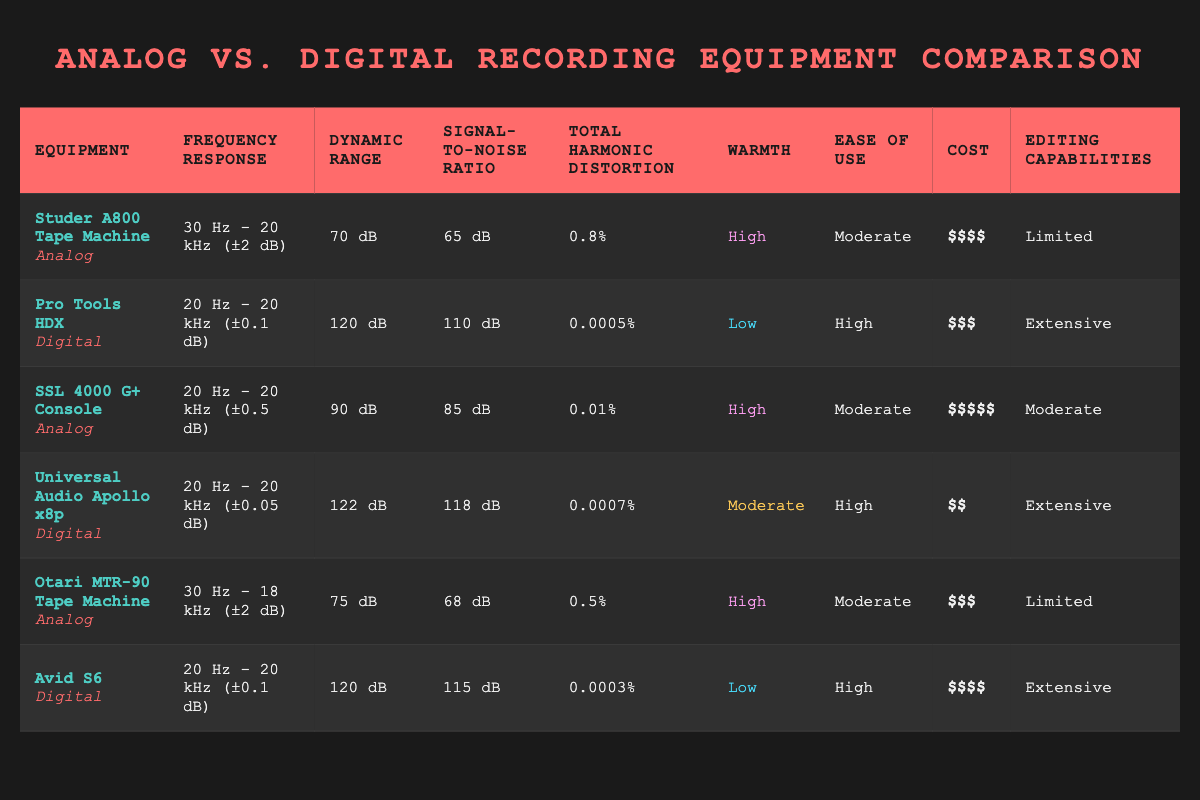What is the frequency response of Pro Tools HDX? The frequency response of Pro Tools HDX is listed in the table as 20 Hz - 20 kHz (±0.1 dB).
Answer: 20 Hz - 20 kHz (±0.1 dB) Which equipment has the highest dynamic range? Looking at the dynamic ranges provided in the table, Pro Tools HDX has a dynamic range of 120 dB, which is the highest among all listed equipment.
Answer: Pro Tools HDX True or false: The Studer A800 Tape Machine has a better signal-to-noise ratio than the Otari MTR-90 Tape Machine. The signal-to-noise ratio for the Studer A800 is 65 dB, and the Otari MTR-90 is 68 dB. Since 65 dB is less than 68 dB, the statement is false.
Answer: False What is the difference in total harmonic distortion between the Universal Audio Apollo x8p and the SSL 4000 G+ Console? The total harmonic distortion for the Universal Audio Apollo x8p is 0.0007%, and for the SSL 4000 G+ Console, it is 0.01%. To find the difference, subtract 0.0007 from 0.01, which equals 0.0093%.
Answer: 0.0093% Which type of equipment, analog or digital, generally exhibits higher warmth according to the table? The table indicates "High" warmth for both the Studer A800 and SSL 4000 G+ Console (analog), while the Pro Tools HDX and Avid S6 (digital) have "Low" warmth. This suggests that analog equipment generally exhibits higher warmth according to these examples.
Answer: Analog 